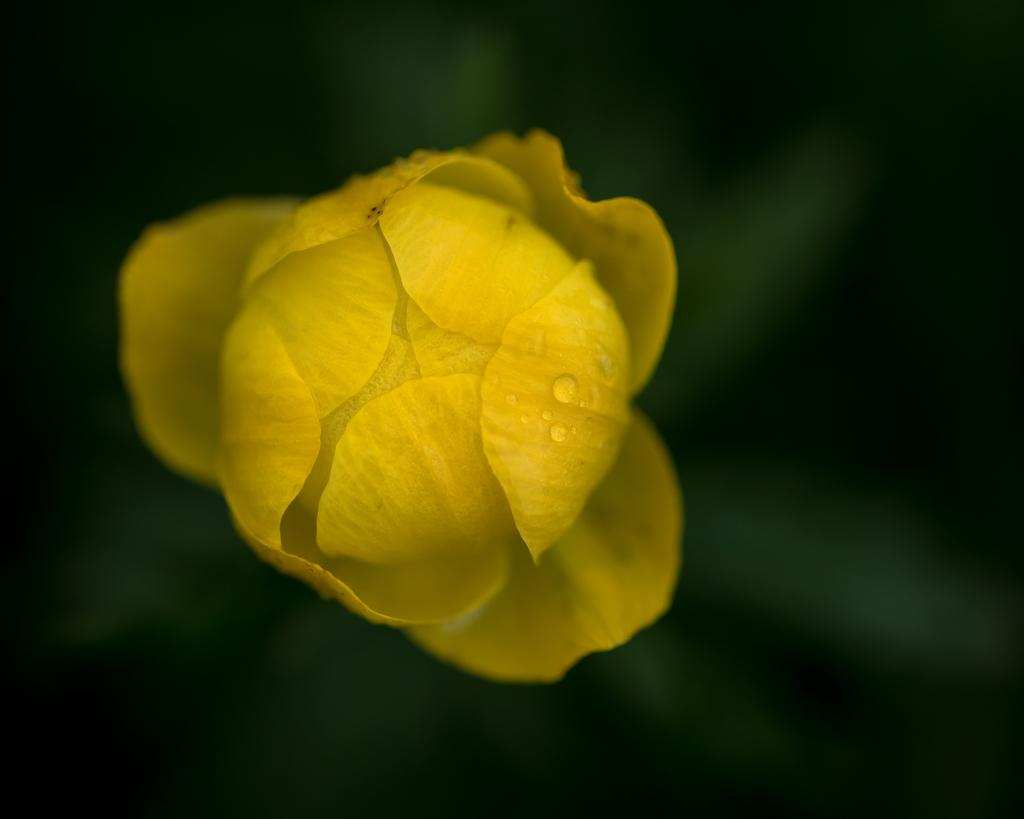What type of flower is present in the image? There is a yellow color flower in the image. Are there any additional features on the flower? Yes, there are water drops on the flower. What is the color of the background in the image? The background of the image is dark in color. How deep is the quicksand surrounding the flower in the image? There is no quicksand present in the image; it features a yellow color flower with water drops and a dark background. What month is it in the image? The image does not provide any information about the month or time of year. 